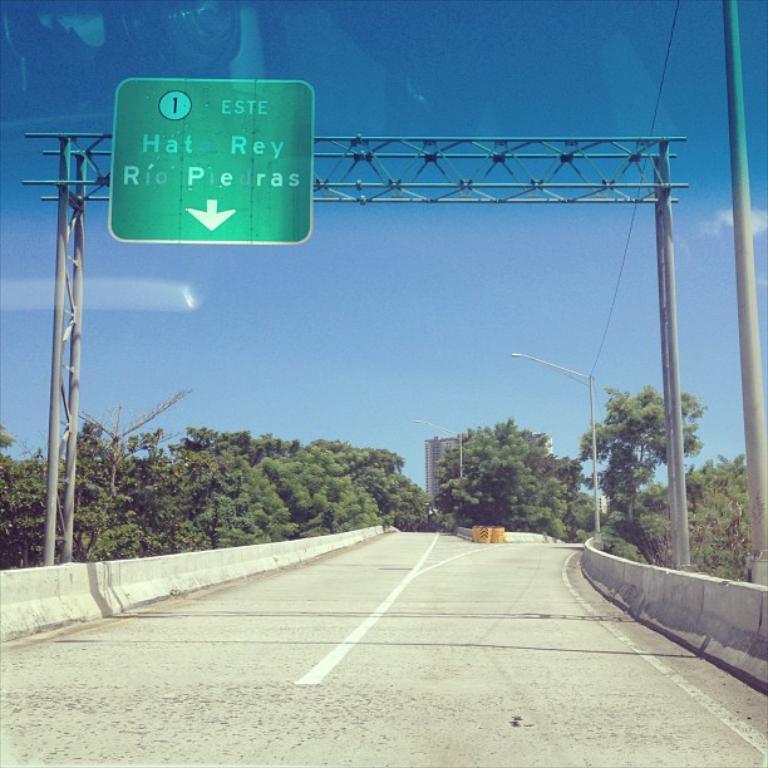Can you describe this image briefly? At the bottom of the image there is road. On the sides of the road there is fencing. And also there are poles with sign board. In the background there are trees. And also there is a pole with streetlight. Behind the trees there is sky. At the top of the image there is sky. 